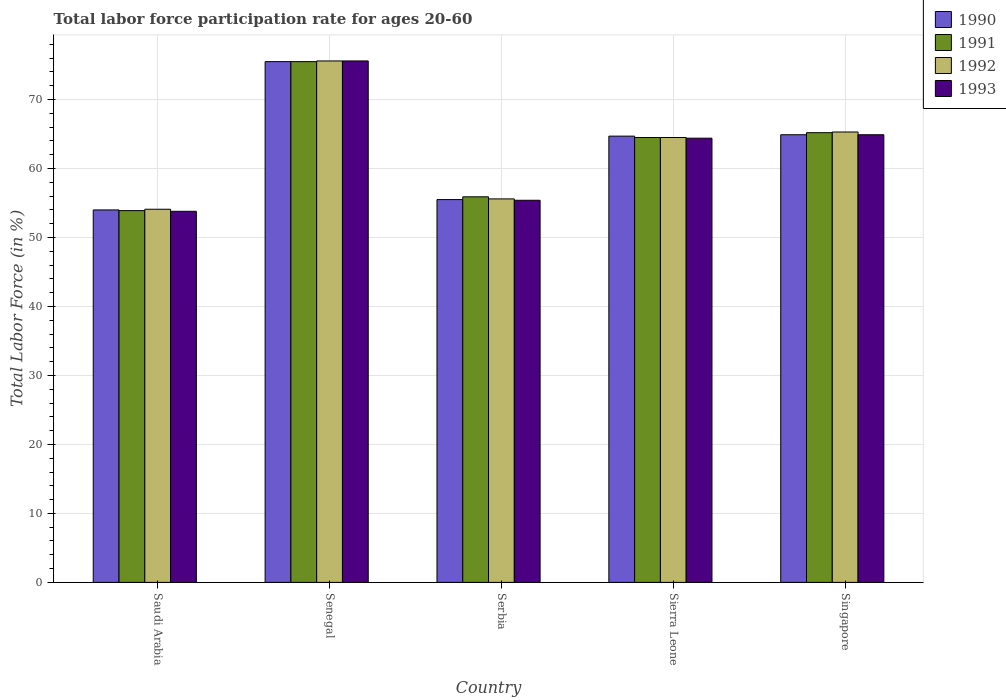Are the number of bars on each tick of the X-axis equal?
Offer a very short reply. Yes. How many bars are there on the 5th tick from the left?
Offer a very short reply. 4. How many bars are there on the 4th tick from the right?
Give a very brief answer. 4. What is the label of the 2nd group of bars from the left?
Offer a terse response. Senegal. In how many cases, is the number of bars for a given country not equal to the number of legend labels?
Your response must be concise. 0. What is the labor force participation rate in 1990 in Senegal?
Your response must be concise. 75.5. Across all countries, what is the maximum labor force participation rate in 1993?
Keep it short and to the point. 75.6. Across all countries, what is the minimum labor force participation rate in 1993?
Ensure brevity in your answer.  53.8. In which country was the labor force participation rate in 1992 maximum?
Offer a terse response. Senegal. In which country was the labor force participation rate in 1993 minimum?
Your answer should be compact. Saudi Arabia. What is the total labor force participation rate in 1992 in the graph?
Offer a very short reply. 315.1. What is the difference between the labor force participation rate in 1992 in Sierra Leone and that in Singapore?
Ensure brevity in your answer.  -0.8. What is the difference between the labor force participation rate in 1992 in Sierra Leone and the labor force participation rate in 1990 in Saudi Arabia?
Offer a very short reply. 10.5. What is the average labor force participation rate in 1992 per country?
Provide a succinct answer. 63.02. What is the difference between the labor force participation rate of/in 1993 and labor force participation rate of/in 1992 in Saudi Arabia?
Provide a short and direct response. -0.3. What is the ratio of the labor force participation rate in 1992 in Serbia to that in Sierra Leone?
Keep it short and to the point. 0.86. Is the labor force participation rate in 1993 in Senegal less than that in Singapore?
Your answer should be compact. No. What is the difference between the highest and the second highest labor force participation rate in 1990?
Offer a very short reply. 0.2. What is the difference between the highest and the lowest labor force participation rate in 1993?
Make the answer very short. 21.8. Is the sum of the labor force participation rate in 1991 in Saudi Arabia and Sierra Leone greater than the maximum labor force participation rate in 1990 across all countries?
Offer a terse response. Yes. What does the 1st bar from the left in Sierra Leone represents?
Provide a succinct answer. 1990. What does the 2nd bar from the right in Singapore represents?
Your response must be concise. 1992. Is it the case that in every country, the sum of the labor force participation rate in 1991 and labor force participation rate in 1993 is greater than the labor force participation rate in 1992?
Offer a very short reply. Yes. How many bars are there?
Offer a very short reply. 20. What is the difference between two consecutive major ticks on the Y-axis?
Provide a short and direct response. 10. Does the graph contain any zero values?
Your answer should be compact. No. Does the graph contain grids?
Give a very brief answer. Yes. Where does the legend appear in the graph?
Offer a terse response. Top right. How many legend labels are there?
Provide a short and direct response. 4. What is the title of the graph?
Offer a very short reply. Total labor force participation rate for ages 20-60. Does "2002" appear as one of the legend labels in the graph?
Offer a very short reply. No. What is the label or title of the X-axis?
Offer a terse response. Country. What is the label or title of the Y-axis?
Your answer should be very brief. Total Labor Force (in %). What is the Total Labor Force (in %) in 1990 in Saudi Arabia?
Provide a short and direct response. 54. What is the Total Labor Force (in %) in 1991 in Saudi Arabia?
Keep it short and to the point. 53.9. What is the Total Labor Force (in %) of 1992 in Saudi Arabia?
Make the answer very short. 54.1. What is the Total Labor Force (in %) in 1993 in Saudi Arabia?
Provide a short and direct response. 53.8. What is the Total Labor Force (in %) in 1990 in Senegal?
Your answer should be very brief. 75.5. What is the Total Labor Force (in %) in 1991 in Senegal?
Your answer should be compact. 75.5. What is the Total Labor Force (in %) in 1992 in Senegal?
Offer a very short reply. 75.6. What is the Total Labor Force (in %) in 1993 in Senegal?
Offer a terse response. 75.6. What is the Total Labor Force (in %) of 1990 in Serbia?
Provide a succinct answer. 55.5. What is the Total Labor Force (in %) of 1991 in Serbia?
Your answer should be very brief. 55.9. What is the Total Labor Force (in %) of 1992 in Serbia?
Keep it short and to the point. 55.6. What is the Total Labor Force (in %) in 1993 in Serbia?
Your response must be concise. 55.4. What is the Total Labor Force (in %) in 1990 in Sierra Leone?
Make the answer very short. 64.7. What is the Total Labor Force (in %) of 1991 in Sierra Leone?
Offer a very short reply. 64.5. What is the Total Labor Force (in %) in 1992 in Sierra Leone?
Keep it short and to the point. 64.5. What is the Total Labor Force (in %) of 1993 in Sierra Leone?
Provide a short and direct response. 64.4. What is the Total Labor Force (in %) in 1990 in Singapore?
Keep it short and to the point. 64.9. What is the Total Labor Force (in %) in 1991 in Singapore?
Offer a terse response. 65.2. What is the Total Labor Force (in %) in 1992 in Singapore?
Give a very brief answer. 65.3. What is the Total Labor Force (in %) in 1993 in Singapore?
Offer a terse response. 64.9. Across all countries, what is the maximum Total Labor Force (in %) in 1990?
Give a very brief answer. 75.5. Across all countries, what is the maximum Total Labor Force (in %) of 1991?
Provide a short and direct response. 75.5. Across all countries, what is the maximum Total Labor Force (in %) of 1992?
Your answer should be compact. 75.6. Across all countries, what is the maximum Total Labor Force (in %) of 1993?
Provide a short and direct response. 75.6. Across all countries, what is the minimum Total Labor Force (in %) in 1990?
Ensure brevity in your answer.  54. Across all countries, what is the minimum Total Labor Force (in %) of 1991?
Offer a very short reply. 53.9. Across all countries, what is the minimum Total Labor Force (in %) in 1992?
Your answer should be compact. 54.1. Across all countries, what is the minimum Total Labor Force (in %) in 1993?
Ensure brevity in your answer.  53.8. What is the total Total Labor Force (in %) in 1990 in the graph?
Give a very brief answer. 314.6. What is the total Total Labor Force (in %) of 1991 in the graph?
Keep it short and to the point. 315. What is the total Total Labor Force (in %) of 1992 in the graph?
Provide a succinct answer. 315.1. What is the total Total Labor Force (in %) of 1993 in the graph?
Provide a succinct answer. 314.1. What is the difference between the Total Labor Force (in %) in 1990 in Saudi Arabia and that in Senegal?
Provide a short and direct response. -21.5. What is the difference between the Total Labor Force (in %) of 1991 in Saudi Arabia and that in Senegal?
Give a very brief answer. -21.6. What is the difference between the Total Labor Force (in %) of 1992 in Saudi Arabia and that in Senegal?
Your answer should be very brief. -21.5. What is the difference between the Total Labor Force (in %) in 1993 in Saudi Arabia and that in Senegal?
Provide a succinct answer. -21.8. What is the difference between the Total Labor Force (in %) of 1993 in Saudi Arabia and that in Serbia?
Your answer should be very brief. -1.6. What is the difference between the Total Labor Force (in %) of 1990 in Saudi Arabia and that in Sierra Leone?
Offer a very short reply. -10.7. What is the difference between the Total Labor Force (in %) in 1992 in Saudi Arabia and that in Sierra Leone?
Your answer should be compact. -10.4. What is the difference between the Total Labor Force (in %) of 1993 in Saudi Arabia and that in Sierra Leone?
Provide a short and direct response. -10.6. What is the difference between the Total Labor Force (in %) of 1991 in Saudi Arabia and that in Singapore?
Your answer should be very brief. -11.3. What is the difference between the Total Labor Force (in %) in 1992 in Saudi Arabia and that in Singapore?
Your response must be concise. -11.2. What is the difference between the Total Labor Force (in %) of 1991 in Senegal and that in Serbia?
Provide a succinct answer. 19.6. What is the difference between the Total Labor Force (in %) of 1992 in Senegal and that in Serbia?
Keep it short and to the point. 20. What is the difference between the Total Labor Force (in %) in 1993 in Senegal and that in Serbia?
Your response must be concise. 20.2. What is the difference between the Total Labor Force (in %) of 1991 in Senegal and that in Sierra Leone?
Ensure brevity in your answer.  11. What is the difference between the Total Labor Force (in %) in 1992 in Senegal and that in Sierra Leone?
Offer a very short reply. 11.1. What is the difference between the Total Labor Force (in %) of 1993 in Senegal and that in Sierra Leone?
Ensure brevity in your answer.  11.2. What is the difference between the Total Labor Force (in %) in 1992 in Senegal and that in Singapore?
Offer a terse response. 10.3. What is the difference between the Total Labor Force (in %) in 1993 in Senegal and that in Singapore?
Give a very brief answer. 10.7. What is the difference between the Total Labor Force (in %) in 1990 in Serbia and that in Sierra Leone?
Offer a terse response. -9.2. What is the difference between the Total Labor Force (in %) of 1991 in Serbia and that in Singapore?
Ensure brevity in your answer.  -9.3. What is the difference between the Total Labor Force (in %) in 1992 in Serbia and that in Singapore?
Offer a terse response. -9.7. What is the difference between the Total Labor Force (in %) in 1993 in Serbia and that in Singapore?
Offer a very short reply. -9.5. What is the difference between the Total Labor Force (in %) in 1990 in Sierra Leone and that in Singapore?
Make the answer very short. -0.2. What is the difference between the Total Labor Force (in %) in 1991 in Sierra Leone and that in Singapore?
Make the answer very short. -0.7. What is the difference between the Total Labor Force (in %) of 1993 in Sierra Leone and that in Singapore?
Offer a terse response. -0.5. What is the difference between the Total Labor Force (in %) of 1990 in Saudi Arabia and the Total Labor Force (in %) of 1991 in Senegal?
Make the answer very short. -21.5. What is the difference between the Total Labor Force (in %) in 1990 in Saudi Arabia and the Total Labor Force (in %) in 1992 in Senegal?
Your answer should be very brief. -21.6. What is the difference between the Total Labor Force (in %) in 1990 in Saudi Arabia and the Total Labor Force (in %) in 1993 in Senegal?
Make the answer very short. -21.6. What is the difference between the Total Labor Force (in %) of 1991 in Saudi Arabia and the Total Labor Force (in %) of 1992 in Senegal?
Provide a short and direct response. -21.7. What is the difference between the Total Labor Force (in %) of 1991 in Saudi Arabia and the Total Labor Force (in %) of 1993 in Senegal?
Keep it short and to the point. -21.7. What is the difference between the Total Labor Force (in %) in 1992 in Saudi Arabia and the Total Labor Force (in %) in 1993 in Senegal?
Ensure brevity in your answer.  -21.5. What is the difference between the Total Labor Force (in %) in 1990 in Saudi Arabia and the Total Labor Force (in %) in 1993 in Serbia?
Make the answer very short. -1.4. What is the difference between the Total Labor Force (in %) in 1991 in Saudi Arabia and the Total Labor Force (in %) in 1993 in Serbia?
Your answer should be very brief. -1.5. What is the difference between the Total Labor Force (in %) in 1990 in Saudi Arabia and the Total Labor Force (in %) in 1991 in Sierra Leone?
Offer a very short reply. -10.5. What is the difference between the Total Labor Force (in %) of 1990 in Saudi Arabia and the Total Labor Force (in %) of 1992 in Sierra Leone?
Provide a succinct answer. -10.5. What is the difference between the Total Labor Force (in %) of 1990 in Saudi Arabia and the Total Labor Force (in %) of 1993 in Sierra Leone?
Your response must be concise. -10.4. What is the difference between the Total Labor Force (in %) of 1991 in Saudi Arabia and the Total Labor Force (in %) of 1993 in Sierra Leone?
Give a very brief answer. -10.5. What is the difference between the Total Labor Force (in %) of 1992 in Saudi Arabia and the Total Labor Force (in %) of 1993 in Sierra Leone?
Your answer should be compact. -10.3. What is the difference between the Total Labor Force (in %) of 1990 in Saudi Arabia and the Total Labor Force (in %) of 1991 in Singapore?
Offer a terse response. -11.2. What is the difference between the Total Labor Force (in %) of 1990 in Saudi Arabia and the Total Labor Force (in %) of 1992 in Singapore?
Give a very brief answer. -11.3. What is the difference between the Total Labor Force (in %) of 1991 in Saudi Arabia and the Total Labor Force (in %) of 1992 in Singapore?
Provide a short and direct response. -11.4. What is the difference between the Total Labor Force (in %) in 1991 in Saudi Arabia and the Total Labor Force (in %) in 1993 in Singapore?
Your response must be concise. -11. What is the difference between the Total Labor Force (in %) of 1990 in Senegal and the Total Labor Force (in %) of 1991 in Serbia?
Your response must be concise. 19.6. What is the difference between the Total Labor Force (in %) in 1990 in Senegal and the Total Labor Force (in %) in 1993 in Serbia?
Offer a terse response. 20.1. What is the difference between the Total Labor Force (in %) of 1991 in Senegal and the Total Labor Force (in %) of 1993 in Serbia?
Your answer should be very brief. 20.1. What is the difference between the Total Labor Force (in %) in 1992 in Senegal and the Total Labor Force (in %) in 1993 in Serbia?
Your response must be concise. 20.2. What is the difference between the Total Labor Force (in %) of 1990 in Senegal and the Total Labor Force (in %) of 1991 in Sierra Leone?
Ensure brevity in your answer.  11. What is the difference between the Total Labor Force (in %) in 1990 in Senegal and the Total Labor Force (in %) in 1993 in Sierra Leone?
Provide a succinct answer. 11.1. What is the difference between the Total Labor Force (in %) in 1991 in Senegal and the Total Labor Force (in %) in 1993 in Sierra Leone?
Offer a very short reply. 11.1. What is the difference between the Total Labor Force (in %) in 1990 in Senegal and the Total Labor Force (in %) in 1991 in Singapore?
Provide a succinct answer. 10.3. What is the difference between the Total Labor Force (in %) of 1990 in Senegal and the Total Labor Force (in %) of 1992 in Singapore?
Your answer should be very brief. 10.2. What is the difference between the Total Labor Force (in %) in 1990 in Senegal and the Total Labor Force (in %) in 1993 in Singapore?
Ensure brevity in your answer.  10.6. What is the difference between the Total Labor Force (in %) in 1991 in Senegal and the Total Labor Force (in %) in 1992 in Singapore?
Your answer should be compact. 10.2. What is the difference between the Total Labor Force (in %) of 1990 in Serbia and the Total Labor Force (in %) of 1991 in Sierra Leone?
Ensure brevity in your answer.  -9. What is the difference between the Total Labor Force (in %) of 1990 in Serbia and the Total Labor Force (in %) of 1992 in Sierra Leone?
Ensure brevity in your answer.  -9. What is the difference between the Total Labor Force (in %) of 1990 in Serbia and the Total Labor Force (in %) of 1991 in Singapore?
Keep it short and to the point. -9.7. What is the difference between the Total Labor Force (in %) in 1990 in Serbia and the Total Labor Force (in %) in 1992 in Singapore?
Offer a very short reply. -9.8. What is the difference between the Total Labor Force (in %) of 1990 in Serbia and the Total Labor Force (in %) of 1993 in Singapore?
Provide a short and direct response. -9.4. What is the difference between the Total Labor Force (in %) of 1991 in Serbia and the Total Labor Force (in %) of 1993 in Singapore?
Your answer should be compact. -9. What is the difference between the Total Labor Force (in %) of 1992 in Serbia and the Total Labor Force (in %) of 1993 in Singapore?
Your response must be concise. -9.3. What is the difference between the Total Labor Force (in %) of 1990 in Sierra Leone and the Total Labor Force (in %) of 1991 in Singapore?
Keep it short and to the point. -0.5. What is the difference between the Total Labor Force (in %) of 1990 in Sierra Leone and the Total Labor Force (in %) of 1992 in Singapore?
Offer a very short reply. -0.6. What is the difference between the Total Labor Force (in %) in 1990 in Sierra Leone and the Total Labor Force (in %) in 1993 in Singapore?
Ensure brevity in your answer.  -0.2. What is the difference between the Total Labor Force (in %) of 1991 in Sierra Leone and the Total Labor Force (in %) of 1992 in Singapore?
Give a very brief answer. -0.8. What is the difference between the Total Labor Force (in %) in 1991 in Sierra Leone and the Total Labor Force (in %) in 1993 in Singapore?
Your answer should be compact. -0.4. What is the average Total Labor Force (in %) in 1990 per country?
Make the answer very short. 62.92. What is the average Total Labor Force (in %) in 1992 per country?
Your response must be concise. 63.02. What is the average Total Labor Force (in %) of 1993 per country?
Ensure brevity in your answer.  62.82. What is the difference between the Total Labor Force (in %) of 1990 and Total Labor Force (in %) of 1991 in Saudi Arabia?
Offer a very short reply. 0.1. What is the difference between the Total Labor Force (in %) in 1991 and Total Labor Force (in %) in 1992 in Saudi Arabia?
Your response must be concise. -0.2. What is the difference between the Total Labor Force (in %) in 1992 and Total Labor Force (in %) in 1993 in Saudi Arabia?
Your response must be concise. 0.3. What is the difference between the Total Labor Force (in %) in 1990 and Total Labor Force (in %) in 1991 in Senegal?
Offer a very short reply. 0. What is the difference between the Total Labor Force (in %) of 1991 and Total Labor Force (in %) of 1992 in Senegal?
Make the answer very short. -0.1. What is the difference between the Total Labor Force (in %) in 1992 and Total Labor Force (in %) in 1993 in Senegal?
Offer a very short reply. 0. What is the difference between the Total Labor Force (in %) in 1990 and Total Labor Force (in %) in 1992 in Serbia?
Provide a short and direct response. -0.1. What is the difference between the Total Labor Force (in %) in 1990 and Total Labor Force (in %) in 1993 in Serbia?
Offer a very short reply. 0.1. What is the difference between the Total Labor Force (in %) of 1991 and Total Labor Force (in %) of 1992 in Serbia?
Keep it short and to the point. 0.3. What is the difference between the Total Labor Force (in %) in 1990 and Total Labor Force (in %) in 1991 in Sierra Leone?
Your response must be concise. 0.2. What is the difference between the Total Labor Force (in %) in 1991 and Total Labor Force (in %) in 1992 in Sierra Leone?
Ensure brevity in your answer.  0. What is the difference between the Total Labor Force (in %) of 1991 and Total Labor Force (in %) of 1993 in Singapore?
Ensure brevity in your answer.  0.3. What is the difference between the Total Labor Force (in %) of 1992 and Total Labor Force (in %) of 1993 in Singapore?
Offer a very short reply. 0.4. What is the ratio of the Total Labor Force (in %) in 1990 in Saudi Arabia to that in Senegal?
Your answer should be very brief. 0.72. What is the ratio of the Total Labor Force (in %) in 1991 in Saudi Arabia to that in Senegal?
Your answer should be compact. 0.71. What is the ratio of the Total Labor Force (in %) of 1992 in Saudi Arabia to that in Senegal?
Offer a very short reply. 0.72. What is the ratio of the Total Labor Force (in %) in 1993 in Saudi Arabia to that in Senegal?
Provide a short and direct response. 0.71. What is the ratio of the Total Labor Force (in %) in 1990 in Saudi Arabia to that in Serbia?
Your answer should be very brief. 0.97. What is the ratio of the Total Labor Force (in %) in 1991 in Saudi Arabia to that in Serbia?
Give a very brief answer. 0.96. What is the ratio of the Total Labor Force (in %) in 1993 in Saudi Arabia to that in Serbia?
Your response must be concise. 0.97. What is the ratio of the Total Labor Force (in %) of 1990 in Saudi Arabia to that in Sierra Leone?
Offer a very short reply. 0.83. What is the ratio of the Total Labor Force (in %) in 1991 in Saudi Arabia to that in Sierra Leone?
Offer a very short reply. 0.84. What is the ratio of the Total Labor Force (in %) in 1992 in Saudi Arabia to that in Sierra Leone?
Your response must be concise. 0.84. What is the ratio of the Total Labor Force (in %) of 1993 in Saudi Arabia to that in Sierra Leone?
Offer a very short reply. 0.84. What is the ratio of the Total Labor Force (in %) in 1990 in Saudi Arabia to that in Singapore?
Provide a succinct answer. 0.83. What is the ratio of the Total Labor Force (in %) of 1991 in Saudi Arabia to that in Singapore?
Provide a succinct answer. 0.83. What is the ratio of the Total Labor Force (in %) of 1992 in Saudi Arabia to that in Singapore?
Offer a terse response. 0.83. What is the ratio of the Total Labor Force (in %) of 1993 in Saudi Arabia to that in Singapore?
Provide a short and direct response. 0.83. What is the ratio of the Total Labor Force (in %) of 1990 in Senegal to that in Serbia?
Provide a short and direct response. 1.36. What is the ratio of the Total Labor Force (in %) of 1991 in Senegal to that in Serbia?
Provide a short and direct response. 1.35. What is the ratio of the Total Labor Force (in %) in 1992 in Senegal to that in Serbia?
Provide a succinct answer. 1.36. What is the ratio of the Total Labor Force (in %) of 1993 in Senegal to that in Serbia?
Offer a very short reply. 1.36. What is the ratio of the Total Labor Force (in %) in 1990 in Senegal to that in Sierra Leone?
Give a very brief answer. 1.17. What is the ratio of the Total Labor Force (in %) of 1991 in Senegal to that in Sierra Leone?
Ensure brevity in your answer.  1.17. What is the ratio of the Total Labor Force (in %) in 1992 in Senegal to that in Sierra Leone?
Your answer should be compact. 1.17. What is the ratio of the Total Labor Force (in %) of 1993 in Senegal to that in Sierra Leone?
Ensure brevity in your answer.  1.17. What is the ratio of the Total Labor Force (in %) in 1990 in Senegal to that in Singapore?
Keep it short and to the point. 1.16. What is the ratio of the Total Labor Force (in %) in 1991 in Senegal to that in Singapore?
Make the answer very short. 1.16. What is the ratio of the Total Labor Force (in %) of 1992 in Senegal to that in Singapore?
Make the answer very short. 1.16. What is the ratio of the Total Labor Force (in %) of 1993 in Senegal to that in Singapore?
Keep it short and to the point. 1.16. What is the ratio of the Total Labor Force (in %) of 1990 in Serbia to that in Sierra Leone?
Offer a very short reply. 0.86. What is the ratio of the Total Labor Force (in %) in 1991 in Serbia to that in Sierra Leone?
Provide a succinct answer. 0.87. What is the ratio of the Total Labor Force (in %) of 1992 in Serbia to that in Sierra Leone?
Ensure brevity in your answer.  0.86. What is the ratio of the Total Labor Force (in %) of 1993 in Serbia to that in Sierra Leone?
Provide a short and direct response. 0.86. What is the ratio of the Total Labor Force (in %) in 1990 in Serbia to that in Singapore?
Your response must be concise. 0.86. What is the ratio of the Total Labor Force (in %) in 1991 in Serbia to that in Singapore?
Ensure brevity in your answer.  0.86. What is the ratio of the Total Labor Force (in %) in 1992 in Serbia to that in Singapore?
Offer a very short reply. 0.85. What is the ratio of the Total Labor Force (in %) of 1993 in Serbia to that in Singapore?
Your response must be concise. 0.85. What is the ratio of the Total Labor Force (in %) in 1991 in Sierra Leone to that in Singapore?
Provide a short and direct response. 0.99. What is the difference between the highest and the second highest Total Labor Force (in %) in 1991?
Keep it short and to the point. 10.3. What is the difference between the highest and the second highest Total Labor Force (in %) in 1993?
Your response must be concise. 10.7. What is the difference between the highest and the lowest Total Labor Force (in %) in 1990?
Give a very brief answer. 21.5. What is the difference between the highest and the lowest Total Labor Force (in %) in 1991?
Ensure brevity in your answer.  21.6. What is the difference between the highest and the lowest Total Labor Force (in %) of 1993?
Your answer should be very brief. 21.8. 